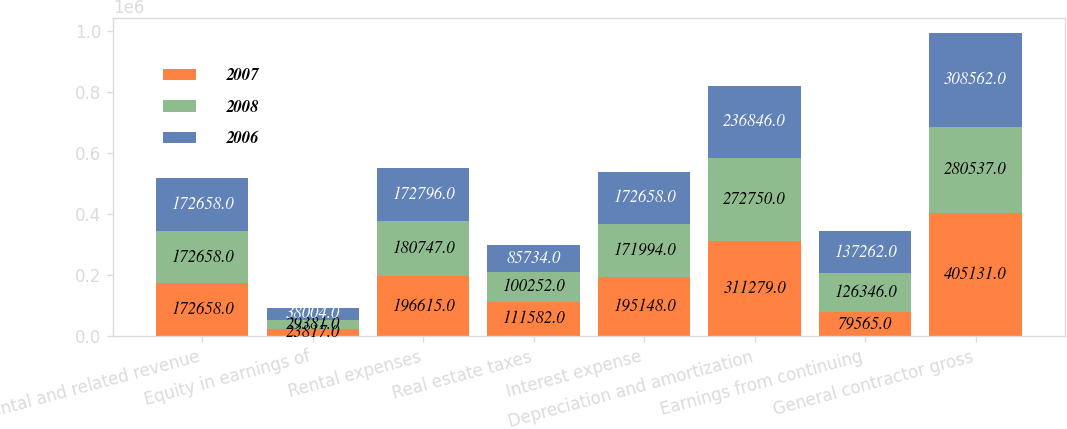Convert chart to OTSL. <chart><loc_0><loc_0><loc_500><loc_500><stacked_bar_chart><ecel><fcel>Rental and related revenue<fcel>Equity in earnings of<fcel>Rental expenses<fcel>Real estate taxes<fcel>Interest expense<fcel>Depreciation and amortization<fcel>Earnings from continuing<fcel>General contractor gross<nl><fcel>2007<fcel>172658<fcel>23817<fcel>196615<fcel>111582<fcel>195148<fcel>311279<fcel>79565<fcel>405131<nl><fcel>2008<fcel>172658<fcel>29381<fcel>180747<fcel>100252<fcel>171994<fcel>272750<fcel>126346<fcel>280537<nl><fcel>2006<fcel>172658<fcel>38004<fcel>172796<fcel>85734<fcel>172658<fcel>236846<fcel>137262<fcel>308562<nl></chart> 